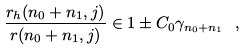Convert formula to latex. <formula><loc_0><loc_0><loc_500><loc_500>\frac { r _ { h } ( n _ { 0 } + n _ { 1 } , j ) } { r ( n _ { 0 } + n _ { 1 } , j ) } \in 1 \pm C _ { 0 } \gamma _ { n _ { 0 } + n _ { 1 } } \ ,</formula> 